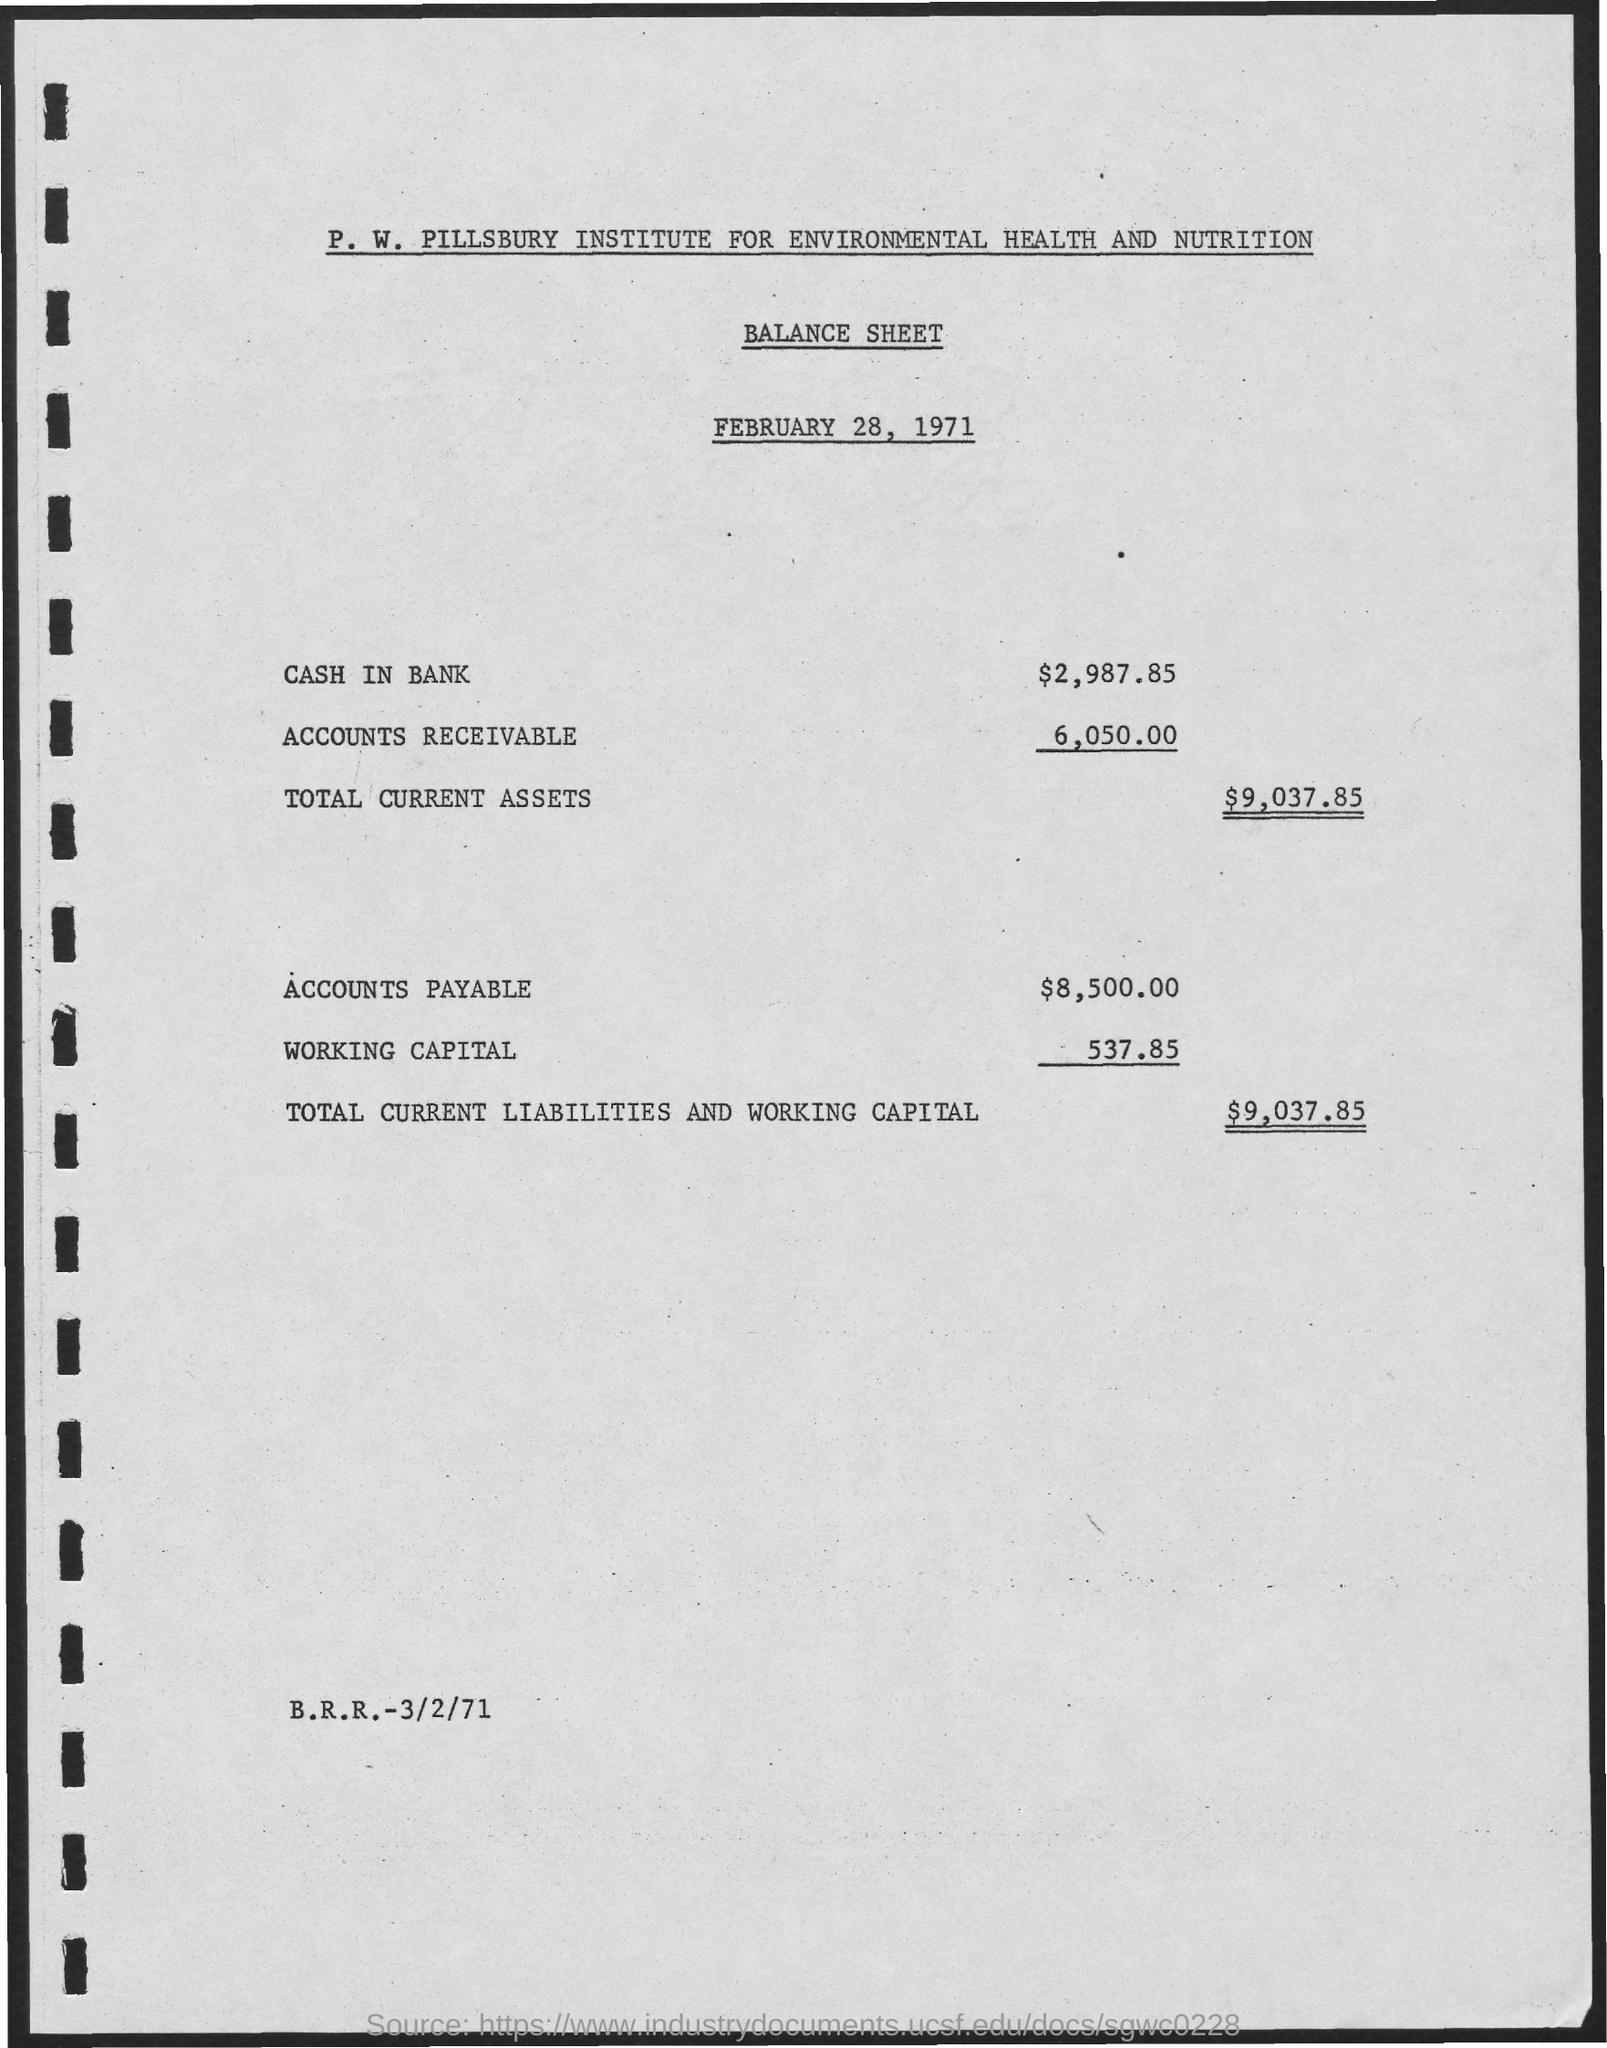What is the date mentioned in the given balance sheet ?
Make the answer very short. February 28, 1971. What is the name of the institute mentioned in the given balance sheet ?
Keep it short and to the point. P.W. Pillsbury institute for environmental health and nutrition. What is the amount mentioned for cash in bank in the balance sheet ?
Offer a very short reply. $ 2,987.85. How much amount is mentioned for accounts  receivable in the given balance sheet ?
Ensure brevity in your answer.  $ 6050.00. What is the amount of total current assets as mentioned in the given balance sheet ?
Provide a short and direct response. $ 9,037.85. How much amount is mentioned at accounts payable in the given balance sheet ?
Provide a succinct answer. $ 8,500.00. What is the amount of working capital as mentioned in the given balance sheet ?
Your answer should be compact. 537.85. What is the amount of  total current liabilities and working capital mentioned in the given balance sheet ?
Provide a succinct answer. $ 9,037.85. 